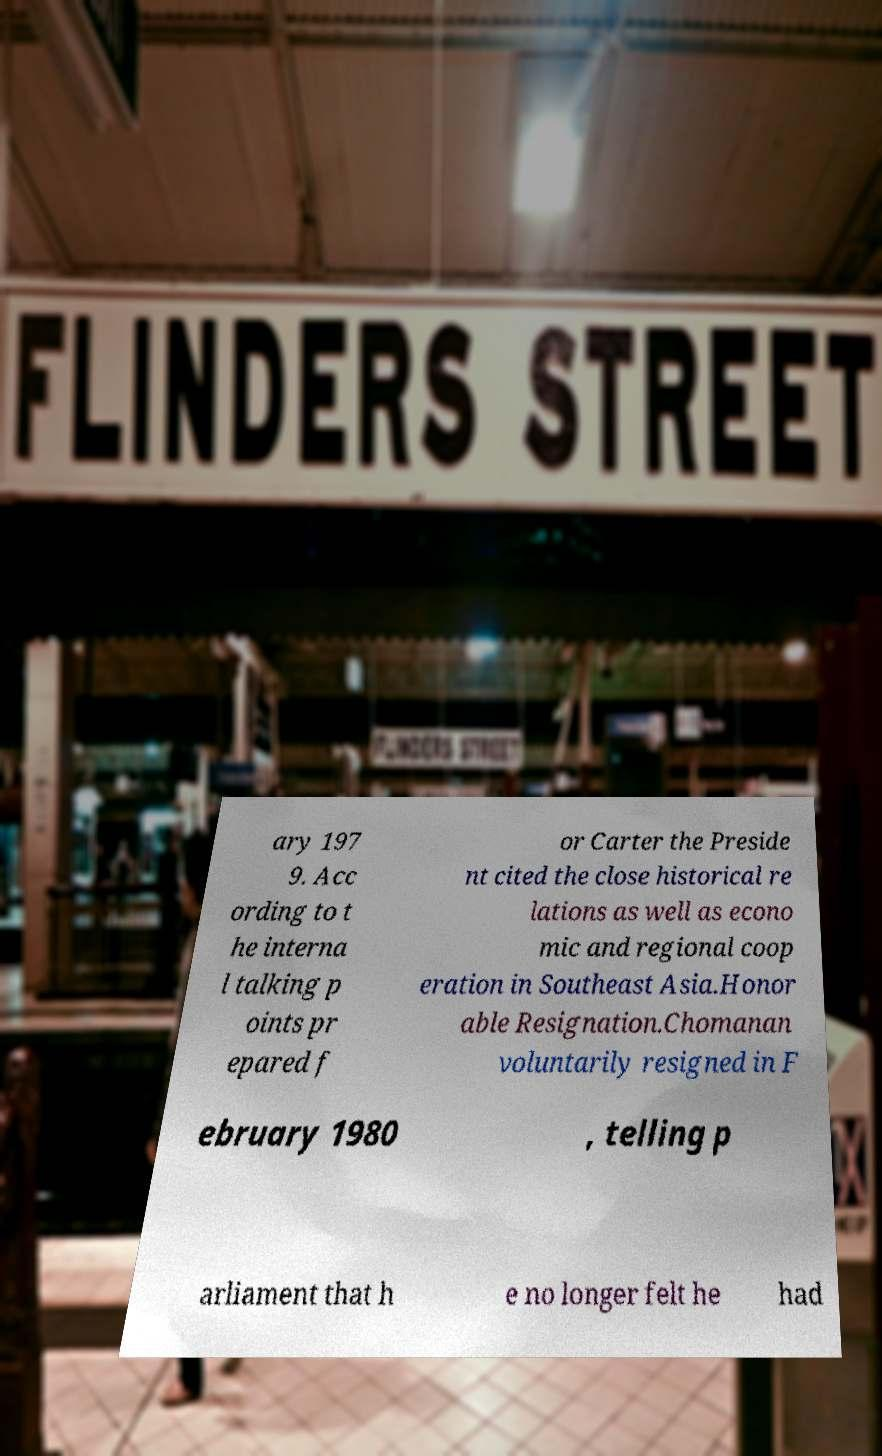Could you assist in decoding the text presented in this image and type it out clearly? ary 197 9. Acc ording to t he interna l talking p oints pr epared f or Carter the Preside nt cited the close historical re lations as well as econo mic and regional coop eration in Southeast Asia.Honor able Resignation.Chomanan voluntarily resigned in F ebruary 1980 , telling p arliament that h e no longer felt he had 